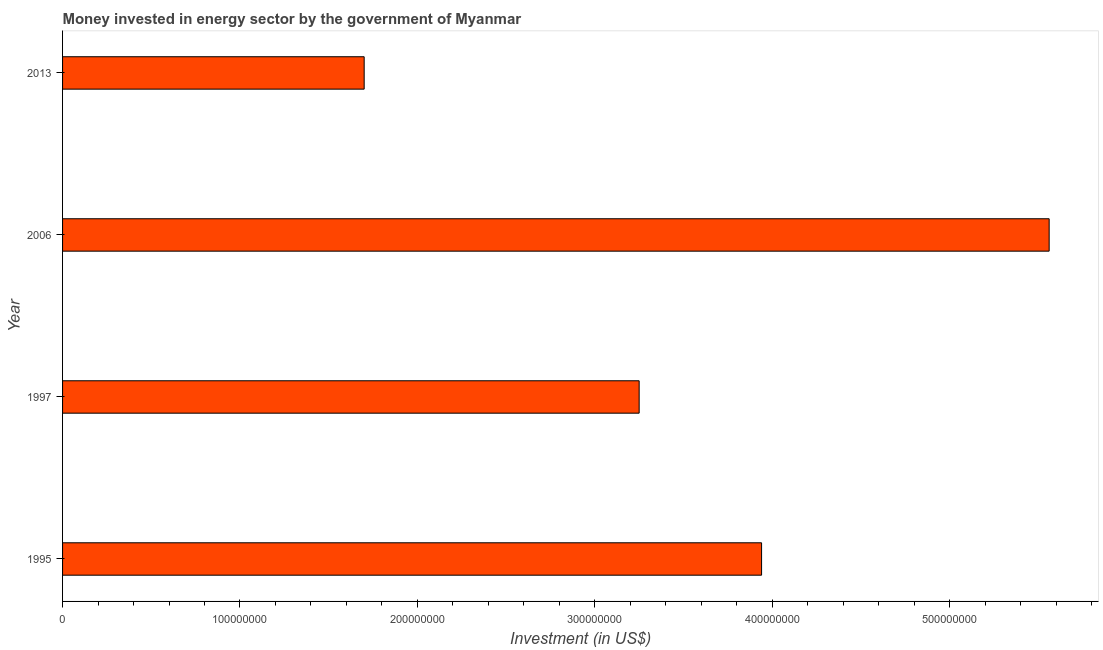What is the title of the graph?
Give a very brief answer. Money invested in energy sector by the government of Myanmar. What is the label or title of the X-axis?
Give a very brief answer. Investment (in US$). What is the label or title of the Y-axis?
Offer a terse response. Year. What is the investment in energy in 2006?
Provide a short and direct response. 5.56e+08. Across all years, what is the maximum investment in energy?
Provide a short and direct response. 5.56e+08. Across all years, what is the minimum investment in energy?
Provide a short and direct response. 1.70e+08. In which year was the investment in energy maximum?
Your answer should be compact. 2006. What is the sum of the investment in energy?
Your response must be concise. 1.45e+09. What is the difference between the investment in energy in 2006 and 2013?
Your response must be concise. 3.86e+08. What is the average investment in energy per year?
Offer a terse response. 3.61e+08. What is the median investment in energy?
Your answer should be very brief. 3.60e+08. In how many years, is the investment in energy greater than 560000000 US$?
Offer a terse response. 0. What is the ratio of the investment in energy in 1997 to that in 2006?
Offer a very short reply. 0.58. Is the investment in energy in 1997 less than that in 2006?
Provide a succinct answer. Yes. What is the difference between the highest and the second highest investment in energy?
Give a very brief answer. 1.62e+08. Is the sum of the investment in energy in 1995 and 2013 greater than the maximum investment in energy across all years?
Give a very brief answer. Yes. What is the difference between the highest and the lowest investment in energy?
Ensure brevity in your answer.  3.86e+08. What is the difference between two consecutive major ticks on the X-axis?
Give a very brief answer. 1.00e+08. Are the values on the major ticks of X-axis written in scientific E-notation?
Your answer should be very brief. No. What is the Investment (in US$) of 1995?
Your answer should be compact. 3.94e+08. What is the Investment (in US$) in 1997?
Ensure brevity in your answer.  3.25e+08. What is the Investment (in US$) of 2006?
Your answer should be very brief. 5.56e+08. What is the Investment (in US$) in 2013?
Make the answer very short. 1.70e+08. What is the difference between the Investment (in US$) in 1995 and 1997?
Your answer should be very brief. 6.90e+07. What is the difference between the Investment (in US$) in 1995 and 2006?
Your answer should be compact. -1.62e+08. What is the difference between the Investment (in US$) in 1995 and 2013?
Give a very brief answer. 2.24e+08. What is the difference between the Investment (in US$) in 1997 and 2006?
Ensure brevity in your answer.  -2.31e+08. What is the difference between the Investment (in US$) in 1997 and 2013?
Provide a short and direct response. 1.55e+08. What is the difference between the Investment (in US$) in 2006 and 2013?
Provide a short and direct response. 3.86e+08. What is the ratio of the Investment (in US$) in 1995 to that in 1997?
Your answer should be compact. 1.21. What is the ratio of the Investment (in US$) in 1995 to that in 2006?
Ensure brevity in your answer.  0.71. What is the ratio of the Investment (in US$) in 1995 to that in 2013?
Your answer should be very brief. 2.32. What is the ratio of the Investment (in US$) in 1997 to that in 2006?
Keep it short and to the point. 0.58. What is the ratio of the Investment (in US$) in 1997 to that in 2013?
Offer a terse response. 1.91. What is the ratio of the Investment (in US$) in 2006 to that in 2013?
Provide a succinct answer. 3.27. 